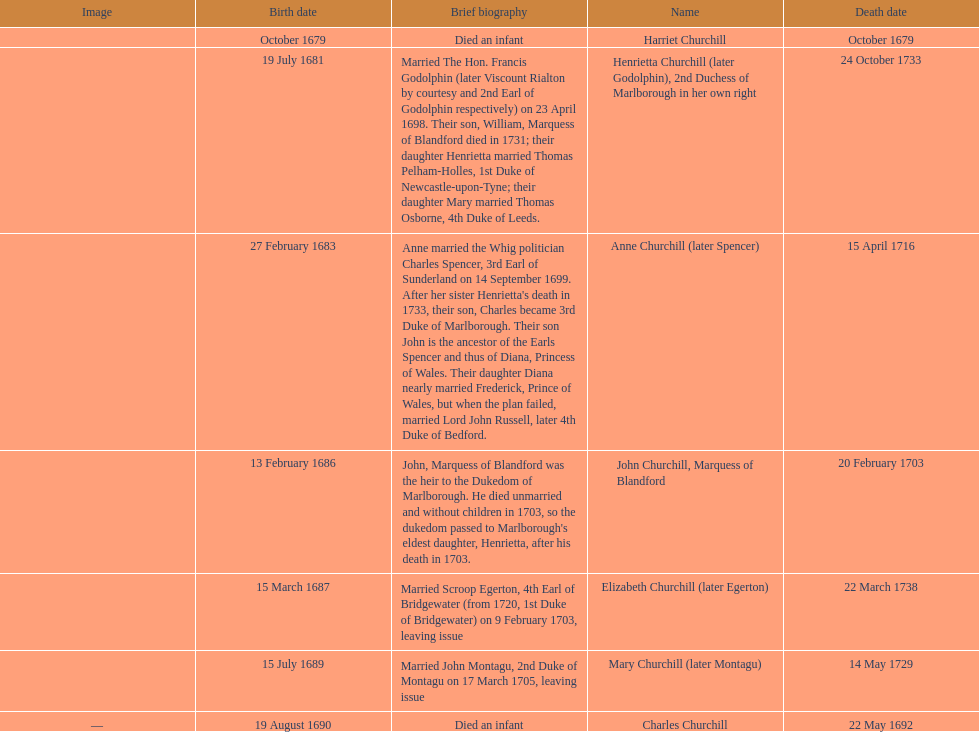What is the total number of children born after 1675? 7. Parse the full table. {'header': ['Image', 'Birth date', 'Brief biography', 'Name', 'Death date'], 'rows': [['', 'October 1679', 'Died an infant', 'Harriet Churchill', 'October 1679'], ['', '19 July 1681', 'Married The Hon. Francis Godolphin (later Viscount Rialton by courtesy and 2nd Earl of Godolphin respectively) on 23 April 1698. Their son, William, Marquess of Blandford died in 1731; their daughter Henrietta married Thomas Pelham-Holles, 1st Duke of Newcastle-upon-Tyne; their daughter Mary married Thomas Osborne, 4th Duke of Leeds.', 'Henrietta Churchill (later Godolphin), 2nd Duchess of Marlborough in her own right', '24 October 1733'], ['', '27 February 1683', "Anne married the Whig politician Charles Spencer, 3rd Earl of Sunderland on 14 September 1699. After her sister Henrietta's death in 1733, their son, Charles became 3rd Duke of Marlborough. Their son John is the ancestor of the Earls Spencer and thus of Diana, Princess of Wales. Their daughter Diana nearly married Frederick, Prince of Wales, but when the plan failed, married Lord John Russell, later 4th Duke of Bedford.", 'Anne Churchill (later Spencer)', '15 April 1716'], ['', '13 February 1686', "John, Marquess of Blandford was the heir to the Dukedom of Marlborough. He died unmarried and without children in 1703, so the dukedom passed to Marlborough's eldest daughter, Henrietta, after his death in 1703.", 'John Churchill, Marquess of Blandford', '20 February 1703'], ['', '15 March 1687', 'Married Scroop Egerton, 4th Earl of Bridgewater (from 1720, 1st Duke of Bridgewater) on 9 February 1703, leaving issue', 'Elizabeth Churchill (later Egerton)', '22 March 1738'], ['', '15 July 1689', 'Married John Montagu, 2nd Duke of Montagu on 17 March 1705, leaving issue', 'Mary Churchill (later Montagu)', '14 May 1729'], ['—', '19 August 1690', 'Died an infant', 'Charles Churchill', '22 May 1692']]} 